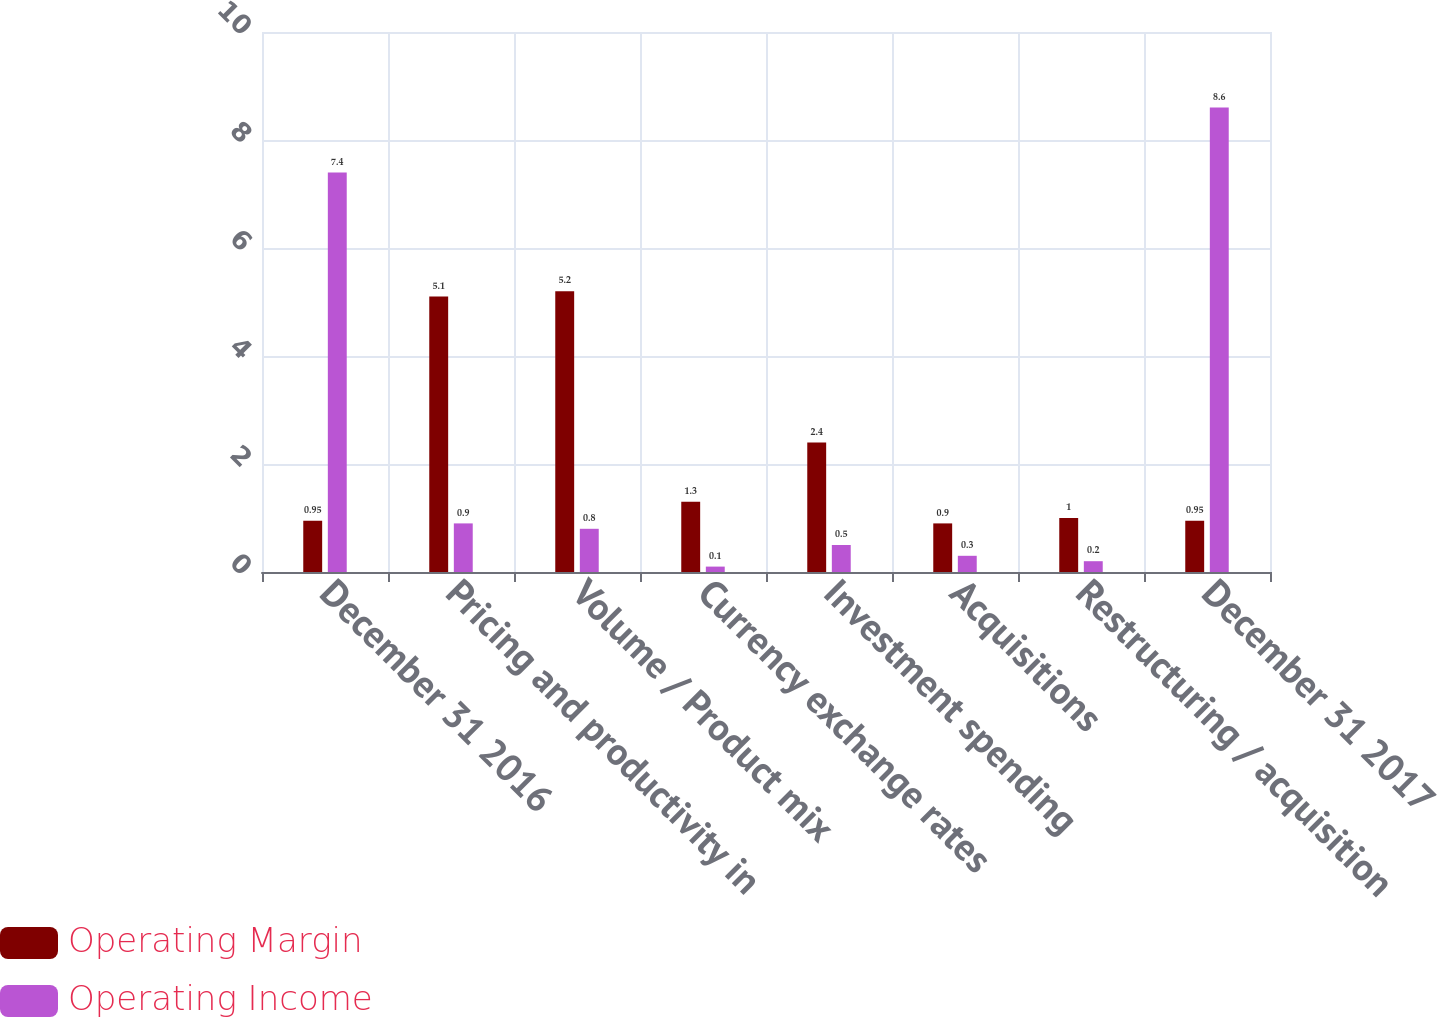Convert chart. <chart><loc_0><loc_0><loc_500><loc_500><stacked_bar_chart><ecel><fcel>December 31 2016<fcel>Pricing and productivity in<fcel>Volume / Product mix<fcel>Currency exchange rates<fcel>Investment spending<fcel>Acquisitions<fcel>Restructuring / acquisition<fcel>December 31 2017<nl><fcel>Operating Margin<fcel>0.95<fcel>5.1<fcel>5.2<fcel>1.3<fcel>2.4<fcel>0.9<fcel>1<fcel>0.95<nl><fcel>Operating Income<fcel>7.4<fcel>0.9<fcel>0.8<fcel>0.1<fcel>0.5<fcel>0.3<fcel>0.2<fcel>8.6<nl></chart> 